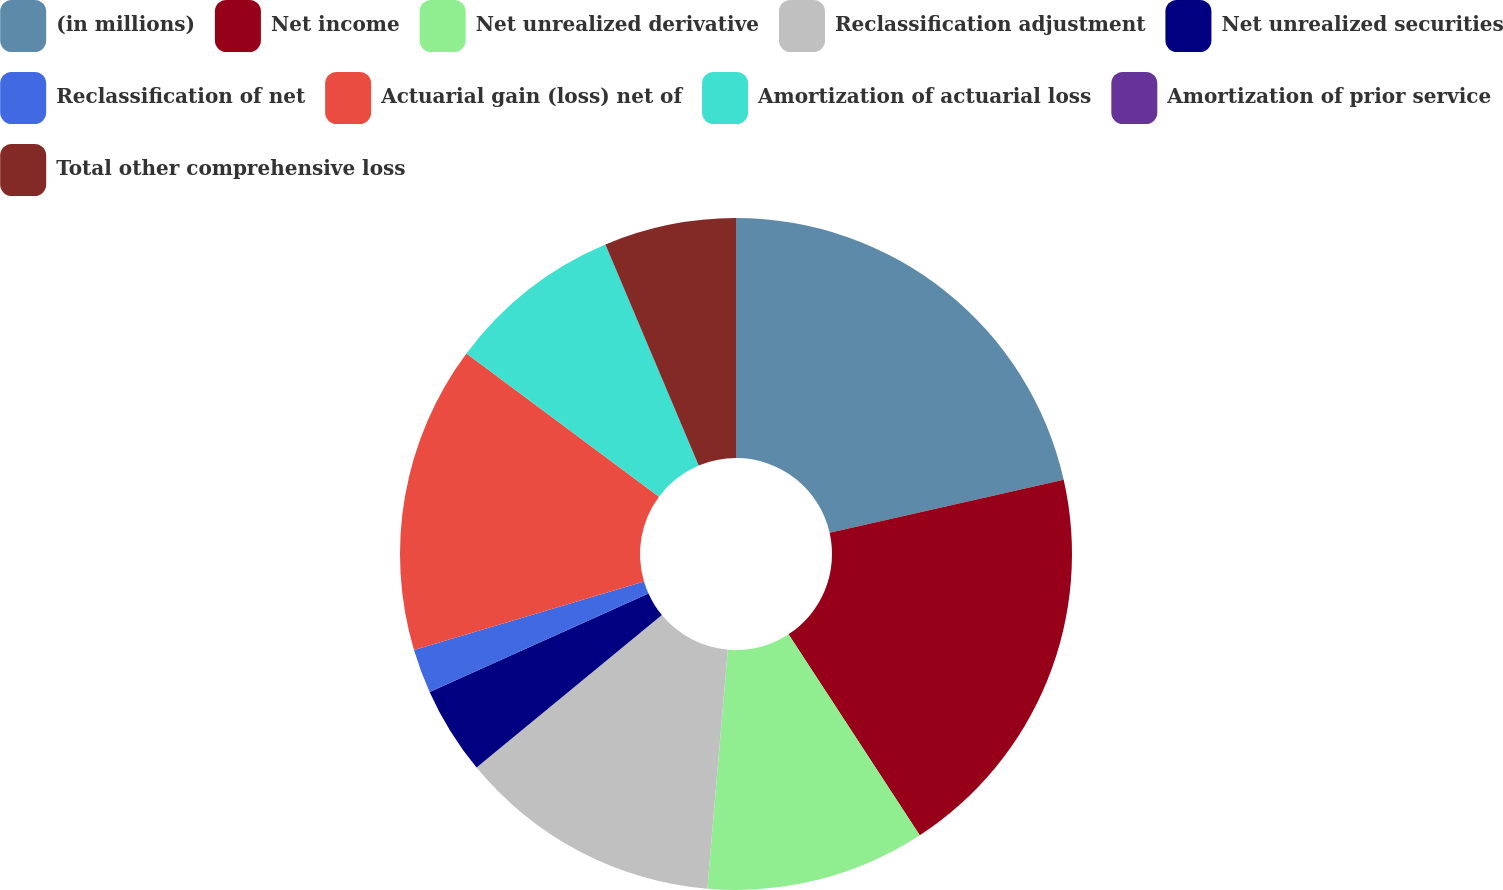Convert chart. <chart><loc_0><loc_0><loc_500><loc_500><pie_chart><fcel>(in millions)<fcel>Net income<fcel>Net unrealized derivative<fcel>Reclassification adjustment<fcel>Net unrealized securities<fcel>Reclassification of net<fcel>Actuarial gain (loss) net of<fcel>Amortization of actuarial loss<fcel>Amortization of prior service<fcel>Total other comprehensive loss<nl><fcel>21.45%<fcel>19.34%<fcel>10.57%<fcel>12.68%<fcel>4.23%<fcel>2.12%<fcel>14.79%<fcel>8.46%<fcel>0.01%<fcel>6.35%<nl></chart> 